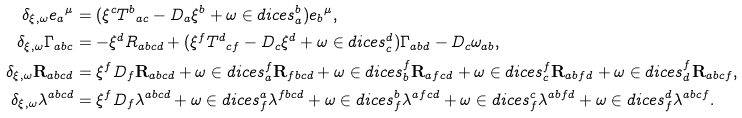Convert formula to latex. <formula><loc_0><loc_0><loc_500><loc_500>\delta _ { \xi , \omega } { e _ { a } } ^ { \mu } & = ( \xi ^ { c } { T ^ { b } } _ { a c } - D _ { a } \xi ^ { b } + { \omega } \in d i c e s { _ { a } ^ { b } } ) { e _ { b } } ^ { \mu } , \\ \delta _ { \xi , \omega } \Gamma _ { a b c } & = - \xi ^ { d } R _ { a b c d } + ( \xi ^ { f } { T ^ { d } } _ { c f } - D _ { c } \xi ^ { d } + \omega \in d i c e s { _ { c } ^ { d } } ) \Gamma _ { a b d } - D _ { c } \omega _ { a b } , \\ \delta _ { \xi , \omega } \mathbf R _ { a b c d } & = \xi ^ { f } D _ { f } \mathbf R _ { a b c d } + { \omega } \in d i c e s { _ { a } ^ { f } } \mathbf R _ { f b c d } + \omega \in d i c e s { _ { b } ^ { f } } \mathbf R _ { a f c d } + \omega \in d i c e s { _ { c } ^ { f } } \mathbf R _ { a b f d } + \omega \in d i c e s { _ { d } ^ { f } } \mathbf R _ { a b c f } , \\ \delta _ { \xi , \omega } \lambda ^ { a b c d } & = \xi ^ { f } D _ { f } \lambda ^ { a b c d } + \omega \in d i c e s { ^ { a } _ { f } } \lambda ^ { f b c d } + \omega \in d i c e s { ^ { b } _ { f } } \lambda ^ { a f c d } + \omega \in d i c e s { ^ { c } _ { f } } \lambda ^ { a b f d } + \omega \in d i c e s { ^ { d } _ { f } } \lambda ^ { a b c f } .</formula> 